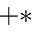Convert formula to latex. <formula><loc_0><loc_0><loc_500><loc_500>^ { + * }</formula> 